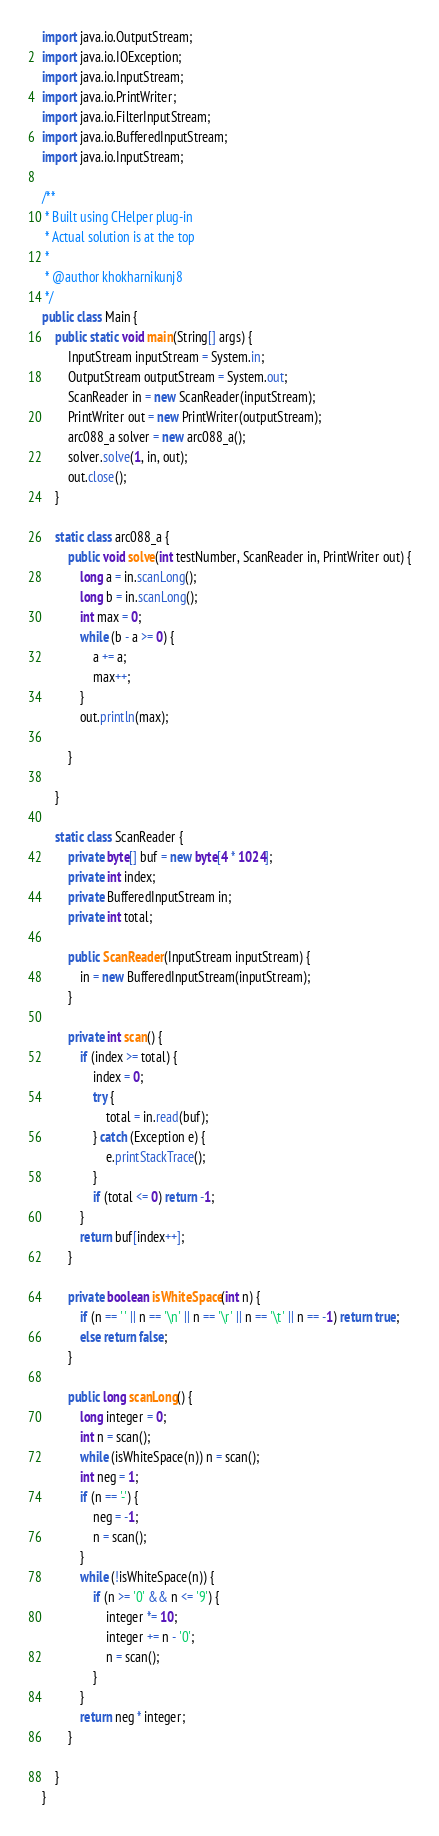<code> <loc_0><loc_0><loc_500><loc_500><_Java_>import java.io.OutputStream;
import java.io.IOException;
import java.io.InputStream;
import java.io.PrintWriter;
import java.io.FilterInputStream;
import java.io.BufferedInputStream;
import java.io.InputStream;

/**
 * Built using CHelper plug-in
 * Actual solution is at the top
 *
 * @author khokharnikunj8
 */
public class Main {
    public static void main(String[] args) {
        InputStream inputStream = System.in;
        OutputStream outputStream = System.out;
        ScanReader in = new ScanReader(inputStream);
        PrintWriter out = new PrintWriter(outputStream);
        arc088_a solver = new arc088_a();
        solver.solve(1, in, out);
        out.close();
    }

    static class arc088_a {
        public void solve(int testNumber, ScanReader in, PrintWriter out) {
            long a = in.scanLong();
            long b = in.scanLong();
            int max = 0;
            while (b - a >= 0) {
                a += a;
                max++;
            }
            out.println(max);

        }

    }

    static class ScanReader {
        private byte[] buf = new byte[4 * 1024];
        private int index;
        private BufferedInputStream in;
        private int total;

        public ScanReader(InputStream inputStream) {
            in = new BufferedInputStream(inputStream);
        }

        private int scan() {
            if (index >= total) {
                index = 0;
                try {
                    total = in.read(buf);
                } catch (Exception e) {
                    e.printStackTrace();
                }
                if (total <= 0) return -1;
            }
            return buf[index++];
        }

        private boolean isWhiteSpace(int n) {
            if (n == ' ' || n == '\n' || n == '\r' || n == '\t' || n == -1) return true;
            else return false;
        }

        public long scanLong() {
            long integer = 0;
            int n = scan();
            while (isWhiteSpace(n)) n = scan();
            int neg = 1;
            if (n == '-') {
                neg = -1;
                n = scan();
            }
            while (!isWhiteSpace(n)) {
                if (n >= '0' && n <= '9') {
                    integer *= 10;
                    integer += n - '0';
                    n = scan();
                }
            }
            return neg * integer;
        }

    }
}

</code> 